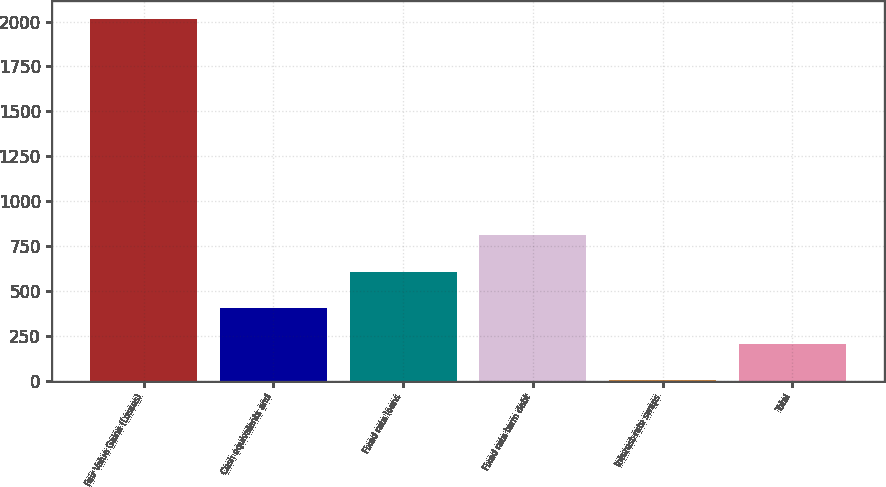<chart> <loc_0><loc_0><loc_500><loc_500><bar_chart><fcel>Fair Value Gains (Losses)<fcel>Cash equivalents and<fcel>Fixed rate loans<fcel>Fixed rate term debt<fcel>Interest-rate swaps<fcel>Total<nl><fcel>2016<fcel>407.04<fcel>608.16<fcel>809.28<fcel>4.8<fcel>205.92<nl></chart> 